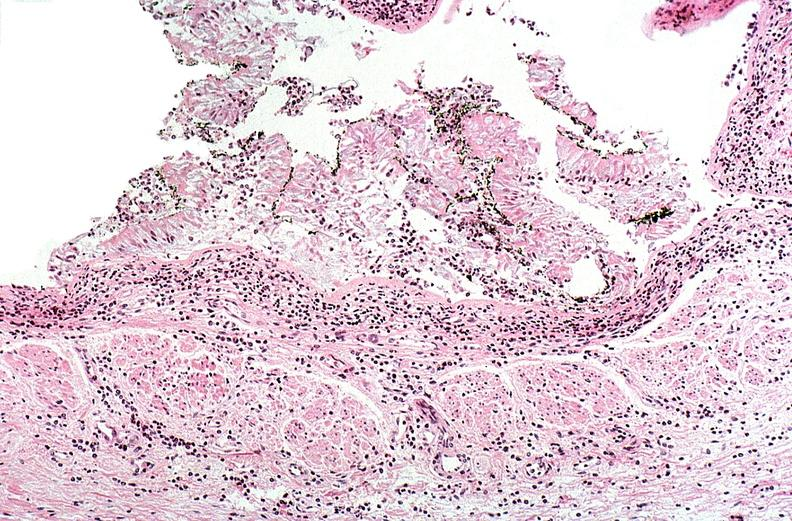s respiratory present?
Answer the question using a single word or phrase. Yes 